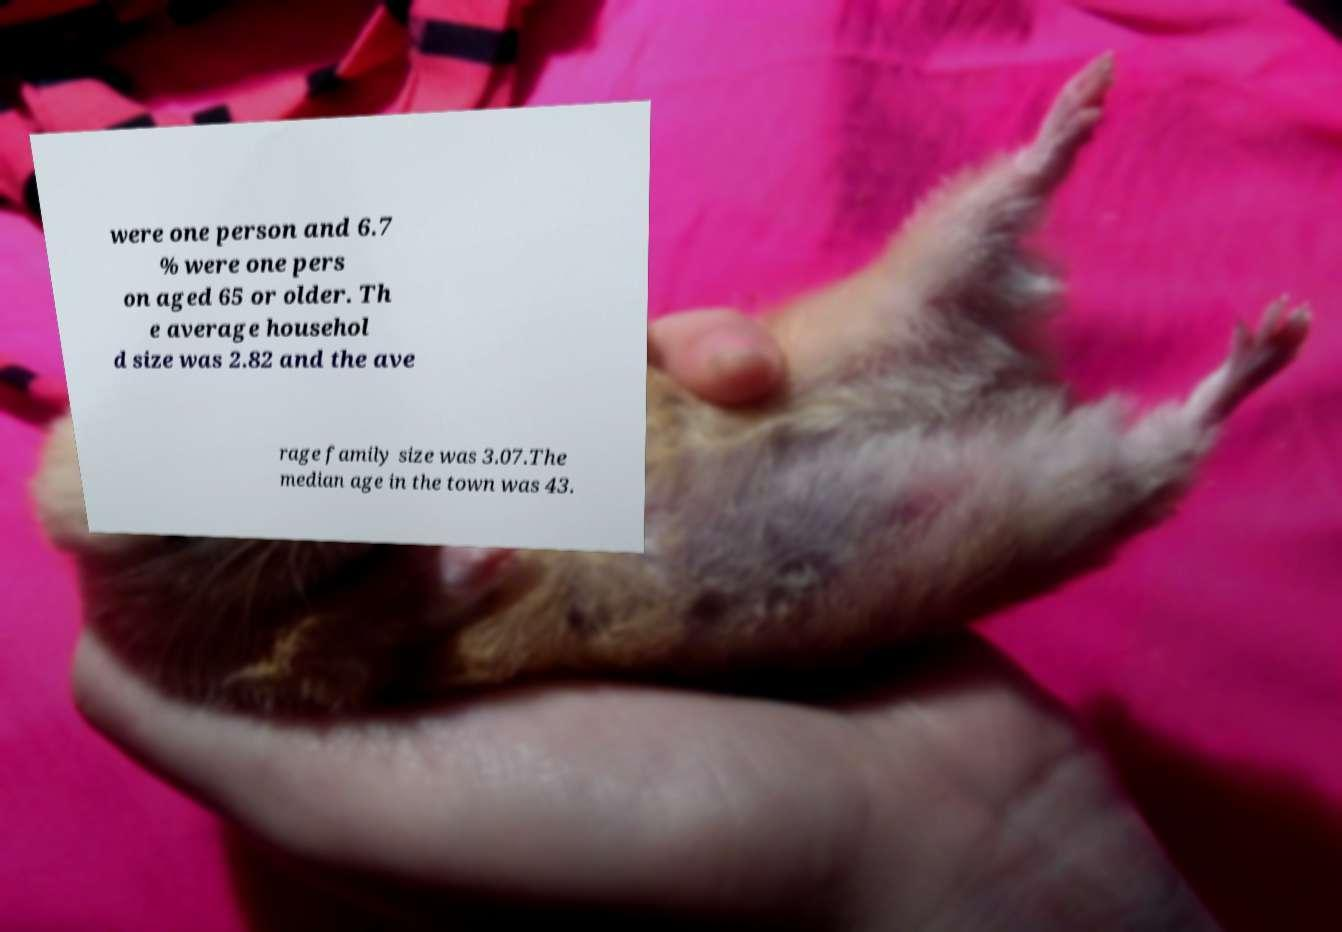Could you extract and type out the text from this image? were one person and 6.7 % were one pers on aged 65 or older. Th e average househol d size was 2.82 and the ave rage family size was 3.07.The median age in the town was 43. 